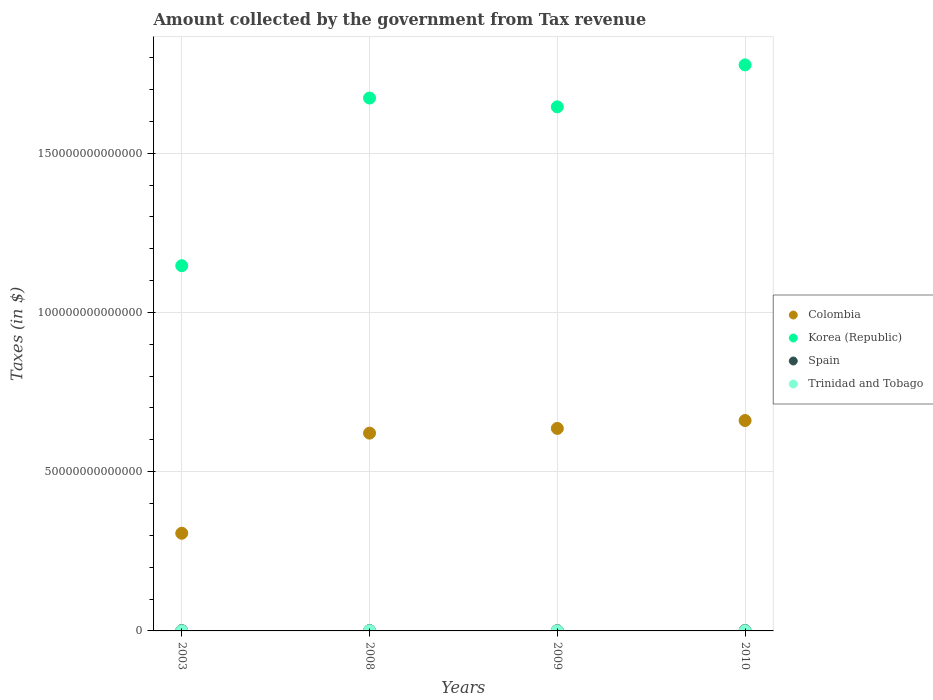Is the number of dotlines equal to the number of legend labels?
Your answer should be very brief. Yes. What is the amount collected by the government from tax revenue in Korea (Republic) in 2009?
Your answer should be very brief. 1.65e+14. Across all years, what is the maximum amount collected by the government from tax revenue in Trinidad and Tobago?
Keep it short and to the point. 5.17e+1. Across all years, what is the minimum amount collected by the government from tax revenue in Korea (Republic)?
Make the answer very short. 1.15e+14. In which year was the amount collected by the government from tax revenue in Spain maximum?
Offer a terse response. 2010. What is the total amount collected by the government from tax revenue in Trinidad and Tobago in the graph?
Offer a very short reply. 1.36e+11. What is the difference between the amount collected by the government from tax revenue in Colombia in 2003 and that in 2008?
Your answer should be very brief. -3.14e+13. What is the difference between the amount collected by the government from tax revenue in Spain in 2008 and the amount collected by the government from tax revenue in Colombia in 2010?
Your answer should be very brief. -6.59e+13. What is the average amount collected by the government from tax revenue in Spain per year?
Make the answer very short. 1.04e+11. In the year 2009, what is the difference between the amount collected by the government from tax revenue in Spain and amount collected by the government from tax revenue in Korea (Republic)?
Offer a very short reply. -1.64e+14. What is the ratio of the amount collected by the government from tax revenue in Korea (Republic) in 2003 to that in 2010?
Your response must be concise. 0.65. What is the difference between the highest and the second highest amount collected by the government from tax revenue in Trinidad and Tobago?
Your response must be concise. 1.46e+1. What is the difference between the highest and the lowest amount collected by the government from tax revenue in Spain?
Keep it short and to the point. 2.95e+1. Is the sum of the amount collected by the government from tax revenue in Korea (Republic) in 2008 and 2009 greater than the maximum amount collected by the government from tax revenue in Spain across all years?
Offer a terse response. Yes. Is it the case that in every year, the sum of the amount collected by the government from tax revenue in Korea (Republic) and amount collected by the government from tax revenue in Colombia  is greater than the sum of amount collected by the government from tax revenue in Trinidad and Tobago and amount collected by the government from tax revenue in Spain?
Give a very brief answer. No. Does the amount collected by the government from tax revenue in Colombia monotonically increase over the years?
Offer a terse response. Yes. How many years are there in the graph?
Ensure brevity in your answer.  4. What is the difference between two consecutive major ticks on the Y-axis?
Your answer should be very brief. 5.00e+13. Are the values on the major ticks of Y-axis written in scientific E-notation?
Offer a terse response. No. Where does the legend appear in the graph?
Provide a short and direct response. Center right. How are the legend labels stacked?
Your response must be concise. Vertical. What is the title of the graph?
Ensure brevity in your answer.  Amount collected by the government from Tax revenue. Does "Germany" appear as one of the legend labels in the graph?
Your answer should be compact. No. What is the label or title of the X-axis?
Ensure brevity in your answer.  Years. What is the label or title of the Y-axis?
Your answer should be compact. Taxes (in $). What is the Taxes (in $) in Colombia in 2003?
Provide a succinct answer. 3.07e+13. What is the Taxes (in $) of Korea (Republic) in 2003?
Offer a very short reply. 1.15e+14. What is the Taxes (in $) in Spain in 2003?
Make the answer very short. 9.47e+1. What is the Taxes (in $) in Trinidad and Tobago in 2003?
Ensure brevity in your answer.  1.52e+1. What is the Taxes (in $) in Colombia in 2008?
Your answer should be very brief. 6.21e+13. What is the Taxes (in $) of Korea (Republic) in 2008?
Provide a short and direct response. 1.67e+14. What is the Taxes (in $) in Spain in 2008?
Your response must be concise. 1.13e+11. What is the Taxes (in $) in Trinidad and Tobago in 2008?
Make the answer very short. 5.17e+1. What is the Taxes (in $) in Colombia in 2009?
Ensure brevity in your answer.  6.36e+13. What is the Taxes (in $) in Korea (Republic) in 2009?
Offer a very short reply. 1.65e+14. What is the Taxes (in $) of Spain in 2009?
Offer a terse response. 9.00e+1. What is the Taxes (in $) in Trinidad and Tobago in 2009?
Give a very brief answer. 3.25e+1. What is the Taxes (in $) of Colombia in 2010?
Offer a terse response. 6.61e+13. What is the Taxes (in $) of Korea (Republic) in 2010?
Provide a short and direct response. 1.78e+14. What is the Taxes (in $) in Spain in 2010?
Keep it short and to the point. 1.19e+11. What is the Taxes (in $) of Trinidad and Tobago in 2010?
Ensure brevity in your answer.  3.71e+1. Across all years, what is the maximum Taxes (in $) of Colombia?
Offer a terse response. 6.61e+13. Across all years, what is the maximum Taxes (in $) of Korea (Republic)?
Provide a short and direct response. 1.78e+14. Across all years, what is the maximum Taxes (in $) in Spain?
Your answer should be very brief. 1.19e+11. Across all years, what is the maximum Taxes (in $) in Trinidad and Tobago?
Ensure brevity in your answer.  5.17e+1. Across all years, what is the minimum Taxes (in $) in Colombia?
Your answer should be very brief. 3.07e+13. Across all years, what is the minimum Taxes (in $) of Korea (Republic)?
Ensure brevity in your answer.  1.15e+14. Across all years, what is the minimum Taxes (in $) in Spain?
Your answer should be very brief. 9.00e+1. Across all years, what is the minimum Taxes (in $) in Trinidad and Tobago?
Provide a short and direct response. 1.52e+1. What is the total Taxes (in $) in Colombia in the graph?
Ensure brevity in your answer.  2.22e+14. What is the total Taxes (in $) in Korea (Republic) in the graph?
Your answer should be very brief. 6.24e+14. What is the total Taxes (in $) of Spain in the graph?
Your answer should be very brief. 4.17e+11. What is the total Taxes (in $) in Trinidad and Tobago in the graph?
Your answer should be compact. 1.36e+11. What is the difference between the Taxes (in $) in Colombia in 2003 and that in 2008?
Provide a succinct answer. -3.14e+13. What is the difference between the Taxes (in $) of Korea (Republic) in 2003 and that in 2008?
Keep it short and to the point. -5.26e+13. What is the difference between the Taxes (in $) of Spain in 2003 and that in 2008?
Offer a very short reply. -1.85e+1. What is the difference between the Taxes (in $) in Trinidad and Tobago in 2003 and that in 2008?
Provide a succinct answer. -3.65e+1. What is the difference between the Taxes (in $) in Colombia in 2003 and that in 2009?
Your answer should be compact. -3.29e+13. What is the difference between the Taxes (in $) in Korea (Republic) in 2003 and that in 2009?
Offer a very short reply. -4.99e+13. What is the difference between the Taxes (in $) of Spain in 2003 and that in 2009?
Give a very brief answer. 4.78e+09. What is the difference between the Taxes (in $) of Trinidad and Tobago in 2003 and that in 2009?
Provide a short and direct response. -1.74e+1. What is the difference between the Taxes (in $) in Colombia in 2003 and that in 2010?
Make the answer very short. -3.54e+13. What is the difference between the Taxes (in $) of Korea (Republic) in 2003 and that in 2010?
Ensure brevity in your answer.  -6.31e+13. What is the difference between the Taxes (in $) in Spain in 2003 and that in 2010?
Provide a succinct answer. -2.47e+1. What is the difference between the Taxes (in $) of Trinidad and Tobago in 2003 and that in 2010?
Ensure brevity in your answer.  -2.19e+1. What is the difference between the Taxes (in $) of Colombia in 2008 and that in 2009?
Ensure brevity in your answer.  -1.47e+12. What is the difference between the Taxes (in $) of Korea (Republic) in 2008 and that in 2009?
Ensure brevity in your answer.  2.76e+12. What is the difference between the Taxes (in $) in Spain in 2008 and that in 2009?
Give a very brief answer. 2.33e+1. What is the difference between the Taxes (in $) of Trinidad and Tobago in 2008 and that in 2009?
Offer a terse response. 1.92e+1. What is the difference between the Taxes (in $) of Colombia in 2008 and that in 2010?
Ensure brevity in your answer.  -3.96e+12. What is the difference between the Taxes (in $) of Korea (Republic) in 2008 and that in 2010?
Provide a short and direct response. -1.04e+13. What is the difference between the Taxes (in $) in Spain in 2008 and that in 2010?
Offer a terse response. -6.20e+09. What is the difference between the Taxes (in $) of Trinidad and Tobago in 2008 and that in 2010?
Provide a short and direct response. 1.46e+1. What is the difference between the Taxes (in $) of Colombia in 2009 and that in 2010?
Provide a succinct answer. -2.49e+12. What is the difference between the Taxes (in $) in Korea (Republic) in 2009 and that in 2010?
Your answer should be compact. -1.32e+13. What is the difference between the Taxes (in $) of Spain in 2009 and that in 2010?
Offer a very short reply. -2.95e+1. What is the difference between the Taxes (in $) of Trinidad and Tobago in 2009 and that in 2010?
Provide a succinct answer. -4.54e+09. What is the difference between the Taxes (in $) in Colombia in 2003 and the Taxes (in $) in Korea (Republic) in 2008?
Offer a very short reply. -1.37e+14. What is the difference between the Taxes (in $) in Colombia in 2003 and the Taxes (in $) in Spain in 2008?
Offer a very short reply. 3.05e+13. What is the difference between the Taxes (in $) of Colombia in 2003 and the Taxes (in $) of Trinidad and Tobago in 2008?
Your response must be concise. 3.06e+13. What is the difference between the Taxes (in $) of Korea (Republic) in 2003 and the Taxes (in $) of Spain in 2008?
Provide a short and direct response. 1.15e+14. What is the difference between the Taxes (in $) of Korea (Republic) in 2003 and the Taxes (in $) of Trinidad and Tobago in 2008?
Provide a short and direct response. 1.15e+14. What is the difference between the Taxes (in $) in Spain in 2003 and the Taxes (in $) in Trinidad and Tobago in 2008?
Give a very brief answer. 4.31e+1. What is the difference between the Taxes (in $) of Colombia in 2003 and the Taxes (in $) of Korea (Republic) in 2009?
Keep it short and to the point. -1.34e+14. What is the difference between the Taxes (in $) in Colombia in 2003 and the Taxes (in $) in Spain in 2009?
Ensure brevity in your answer.  3.06e+13. What is the difference between the Taxes (in $) of Colombia in 2003 and the Taxes (in $) of Trinidad and Tobago in 2009?
Offer a terse response. 3.06e+13. What is the difference between the Taxes (in $) of Korea (Republic) in 2003 and the Taxes (in $) of Spain in 2009?
Your response must be concise. 1.15e+14. What is the difference between the Taxes (in $) of Korea (Republic) in 2003 and the Taxes (in $) of Trinidad and Tobago in 2009?
Your response must be concise. 1.15e+14. What is the difference between the Taxes (in $) in Spain in 2003 and the Taxes (in $) in Trinidad and Tobago in 2009?
Your answer should be compact. 6.22e+1. What is the difference between the Taxes (in $) in Colombia in 2003 and the Taxes (in $) in Korea (Republic) in 2010?
Provide a short and direct response. -1.47e+14. What is the difference between the Taxes (in $) in Colombia in 2003 and the Taxes (in $) in Spain in 2010?
Offer a very short reply. 3.05e+13. What is the difference between the Taxes (in $) in Colombia in 2003 and the Taxes (in $) in Trinidad and Tobago in 2010?
Your response must be concise. 3.06e+13. What is the difference between the Taxes (in $) in Korea (Republic) in 2003 and the Taxes (in $) in Spain in 2010?
Ensure brevity in your answer.  1.15e+14. What is the difference between the Taxes (in $) in Korea (Republic) in 2003 and the Taxes (in $) in Trinidad and Tobago in 2010?
Ensure brevity in your answer.  1.15e+14. What is the difference between the Taxes (in $) of Spain in 2003 and the Taxes (in $) of Trinidad and Tobago in 2010?
Keep it short and to the point. 5.77e+1. What is the difference between the Taxes (in $) of Colombia in 2008 and the Taxes (in $) of Korea (Republic) in 2009?
Give a very brief answer. -1.02e+14. What is the difference between the Taxes (in $) in Colombia in 2008 and the Taxes (in $) in Spain in 2009?
Keep it short and to the point. 6.20e+13. What is the difference between the Taxes (in $) in Colombia in 2008 and the Taxes (in $) in Trinidad and Tobago in 2009?
Offer a very short reply. 6.21e+13. What is the difference between the Taxes (in $) in Korea (Republic) in 2008 and the Taxes (in $) in Spain in 2009?
Keep it short and to the point. 1.67e+14. What is the difference between the Taxes (in $) in Korea (Republic) in 2008 and the Taxes (in $) in Trinidad and Tobago in 2009?
Make the answer very short. 1.67e+14. What is the difference between the Taxes (in $) in Spain in 2008 and the Taxes (in $) in Trinidad and Tobago in 2009?
Offer a very short reply. 8.07e+1. What is the difference between the Taxes (in $) of Colombia in 2008 and the Taxes (in $) of Korea (Republic) in 2010?
Give a very brief answer. -1.16e+14. What is the difference between the Taxes (in $) in Colombia in 2008 and the Taxes (in $) in Spain in 2010?
Offer a very short reply. 6.20e+13. What is the difference between the Taxes (in $) of Colombia in 2008 and the Taxes (in $) of Trinidad and Tobago in 2010?
Give a very brief answer. 6.21e+13. What is the difference between the Taxes (in $) of Korea (Republic) in 2008 and the Taxes (in $) of Spain in 2010?
Keep it short and to the point. 1.67e+14. What is the difference between the Taxes (in $) of Korea (Republic) in 2008 and the Taxes (in $) of Trinidad and Tobago in 2010?
Keep it short and to the point. 1.67e+14. What is the difference between the Taxes (in $) in Spain in 2008 and the Taxes (in $) in Trinidad and Tobago in 2010?
Provide a succinct answer. 7.62e+1. What is the difference between the Taxes (in $) in Colombia in 2009 and the Taxes (in $) in Korea (Republic) in 2010?
Keep it short and to the point. -1.14e+14. What is the difference between the Taxes (in $) of Colombia in 2009 and the Taxes (in $) of Spain in 2010?
Give a very brief answer. 6.35e+13. What is the difference between the Taxes (in $) of Colombia in 2009 and the Taxes (in $) of Trinidad and Tobago in 2010?
Ensure brevity in your answer.  6.35e+13. What is the difference between the Taxes (in $) in Korea (Republic) in 2009 and the Taxes (in $) in Spain in 2010?
Your response must be concise. 1.64e+14. What is the difference between the Taxes (in $) of Korea (Republic) in 2009 and the Taxes (in $) of Trinidad and Tobago in 2010?
Give a very brief answer. 1.65e+14. What is the difference between the Taxes (in $) in Spain in 2009 and the Taxes (in $) in Trinidad and Tobago in 2010?
Make the answer very short. 5.29e+1. What is the average Taxes (in $) of Colombia per year?
Make the answer very short. 5.56e+13. What is the average Taxes (in $) in Korea (Republic) per year?
Your answer should be compact. 1.56e+14. What is the average Taxes (in $) of Spain per year?
Give a very brief answer. 1.04e+11. What is the average Taxes (in $) in Trinidad and Tobago per year?
Your answer should be very brief. 3.41e+1. In the year 2003, what is the difference between the Taxes (in $) in Colombia and Taxes (in $) in Korea (Republic)?
Keep it short and to the point. -8.40e+13. In the year 2003, what is the difference between the Taxes (in $) in Colombia and Taxes (in $) in Spain?
Offer a very short reply. 3.06e+13. In the year 2003, what is the difference between the Taxes (in $) of Colombia and Taxes (in $) of Trinidad and Tobago?
Give a very brief answer. 3.06e+13. In the year 2003, what is the difference between the Taxes (in $) in Korea (Republic) and Taxes (in $) in Spain?
Offer a terse response. 1.15e+14. In the year 2003, what is the difference between the Taxes (in $) of Korea (Republic) and Taxes (in $) of Trinidad and Tobago?
Ensure brevity in your answer.  1.15e+14. In the year 2003, what is the difference between the Taxes (in $) of Spain and Taxes (in $) of Trinidad and Tobago?
Make the answer very short. 7.96e+1. In the year 2008, what is the difference between the Taxes (in $) in Colombia and Taxes (in $) in Korea (Republic)?
Ensure brevity in your answer.  -1.05e+14. In the year 2008, what is the difference between the Taxes (in $) of Colombia and Taxes (in $) of Spain?
Provide a succinct answer. 6.20e+13. In the year 2008, what is the difference between the Taxes (in $) of Colombia and Taxes (in $) of Trinidad and Tobago?
Keep it short and to the point. 6.21e+13. In the year 2008, what is the difference between the Taxes (in $) of Korea (Republic) and Taxes (in $) of Spain?
Make the answer very short. 1.67e+14. In the year 2008, what is the difference between the Taxes (in $) of Korea (Republic) and Taxes (in $) of Trinidad and Tobago?
Make the answer very short. 1.67e+14. In the year 2008, what is the difference between the Taxes (in $) of Spain and Taxes (in $) of Trinidad and Tobago?
Provide a succinct answer. 6.16e+1. In the year 2009, what is the difference between the Taxes (in $) in Colombia and Taxes (in $) in Korea (Republic)?
Your answer should be compact. -1.01e+14. In the year 2009, what is the difference between the Taxes (in $) of Colombia and Taxes (in $) of Spain?
Keep it short and to the point. 6.35e+13. In the year 2009, what is the difference between the Taxes (in $) of Colombia and Taxes (in $) of Trinidad and Tobago?
Your response must be concise. 6.35e+13. In the year 2009, what is the difference between the Taxes (in $) of Korea (Republic) and Taxes (in $) of Spain?
Offer a terse response. 1.64e+14. In the year 2009, what is the difference between the Taxes (in $) of Korea (Republic) and Taxes (in $) of Trinidad and Tobago?
Provide a succinct answer. 1.65e+14. In the year 2009, what is the difference between the Taxes (in $) in Spain and Taxes (in $) in Trinidad and Tobago?
Offer a very short reply. 5.74e+1. In the year 2010, what is the difference between the Taxes (in $) in Colombia and Taxes (in $) in Korea (Republic)?
Keep it short and to the point. -1.12e+14. In the year 2010, what is the difference between the Taxes (in $) in Colombia and Taxes (in $) in Spain?
Give a very brief answer. 6.59e+13. In the year 2010, what is the difference between the Taxes (in $) of Colombia and Taxes (in $) of Trinidad and Tobago?
Your answer should be compact. 6.60e+13. In the year 2010, what is the difference between the Taxes (in $) in Korea (Republic) and Taxes (in $) in Spain?
Offer a terse response. 1.78e+14. In the year 2010, what is the difference between the Taxes (in $) in Korea (Republic) and Taxes (in $) in Trinidad and Tobago?
Keep it short and to the point. 1.78e+14. In the year 2010, what is the difference between the Taxes (in $) of Spain and Taxes (in $) of Trinidad and Tobago?
Make the answer very short. 8.24e+1. What is the ratio of the Taxes (in $) in Colombia in 2003 to that in 2008?
Keep it short and to the point. 0.49. What is the ratio of the Taxes (in $) of Korea (Republic) in 2003 to that in 2008?
Give a very brief answer. 0.69. What is the ratio of the Taxes (in $) of Spain in 2003 to that in 2008?
Your answer should be very brief. 0.84. What is the ratio of the Taxes (in $) of Trinidad and Tobago in 2003 to that in 2008?
Offer a very short reply. 0.29. What is the ratio of the Taxes (in $) in Colombia in 2003 to that in 2009?
Ensure brevity in your answer.  0.48. What is the ratio of the Taxes (in $) in Korea (Republic) in 2003 to that in 2009?
Offer a very short reply. 0.7. What is the ratio of the Taxes (in $) in Spain in 2003 to that in 2009?
Offer a terse response. 1.05. What is the ratio of the Taxes (in $) of Trinidad and Tobago in 2003 to that in 2009?
Your answer should be very brief. 0.47. What is the ratio of the Taxes (in $) in Colombia in 2003 to that in 2010?
Offer a terse response. 0.46. What is the ratio of the Taxes (in $) of Korea (Republic) in 2003 to that in 2010?
Keep it short and to the point. 0.65. What is the ratio of the Taxes (in $) in Spain in 2003 to that in 2010?
Provide a succinct answer. 0.79. What is the ratio of the Taxes (in $) of Trinidad and Tobago in 2003 to that in 2010?
Offer a terse response. 0.41. What is the ratio of the Taxes (in $) of Colombia in 2008 to that in 2009?
Ensure brevity in your answer.  0.98. What is the ratio of the Taxes (in $) of Korea (Republic) in 2008 to that in 2009?
Offer a very short reply. 1.02. What is the ratio of the Taxes (in $) of Spain in 2008 to that in 2009?
Offer a very short reply. 1.26. What is the ratio of the Taxes (in $) in Trinidad and Tobago in 2008 to that in 2009?
Your answer should be compact. 1.59. What is the ratio of the Taxes (in $) in Colombia in 2008 to that in 2010?
Keep it short and to the point. 0.94. What is the ratio of the Taxes (in $) of Korea (Republic) in 2008 to that in 2010?
Offer a very short reply. 0.94. What is the ratio of the Taxes (in $) of Spain in 2008 to that in 2010?
Your answer should be very brief. 0.95. What is the ratio of the Taxes (in $) in Trinidad and Tobago in 2008 to that in 2010?
Your answer should be very brief. 1.39. What is the ratio of the Taxes (in $) in Colombia in 2009 to that in 2010?
Keep it short and to the point. 0.96. What is the ratio of the Taxes (in $) in Korea (Republic) in 2009 to that in 2010?
Your answer should be very brief. 0.93. What is the ratio of the Taxes (in $) in Spain in 2009 to that in 2010?
Your answer should be very brief. 0.75. What is the ratio of the Taxes (in $) of Trinidad and Tobago in 2009 to that in 2010?
Your response must be concise. 0.88. What is the difference between the highest and the second highest Taxes (in $) in Colombia?
Offer a terse response. 2.49e+12. What is the difference between the highest and the second highest Taxes (in $) in Korea (Republic)?
Your answer should be very brief. 1.04e+13. What is the difference between the highest and the second highest Taxes (in $) in Spain?
Keep it short and to the point. 6.20e+09. What is the difference between the highest and the second highest Taxes (in $) of Trinidad and Tobago?
Your answer should be compact. 1.46e+1. What is the difference between the highest and the lowest Taxes (in $) of Colombia?
Offer a very short reply. 3.54e+13. What is the difference between the highest and the lowest Taxes (in $) in Korea (Republic)?
Give a very brief answer. 6.31e+13. What is the difference between the highest and the lowest Taxes (in $) of Spain?
Make the answer very short. 2.95e+1. What is the difference between the highest and the lowest Taxes (in $) of Trinidad and Tobago?
Provide a short and direct response. 3.65e+1. 